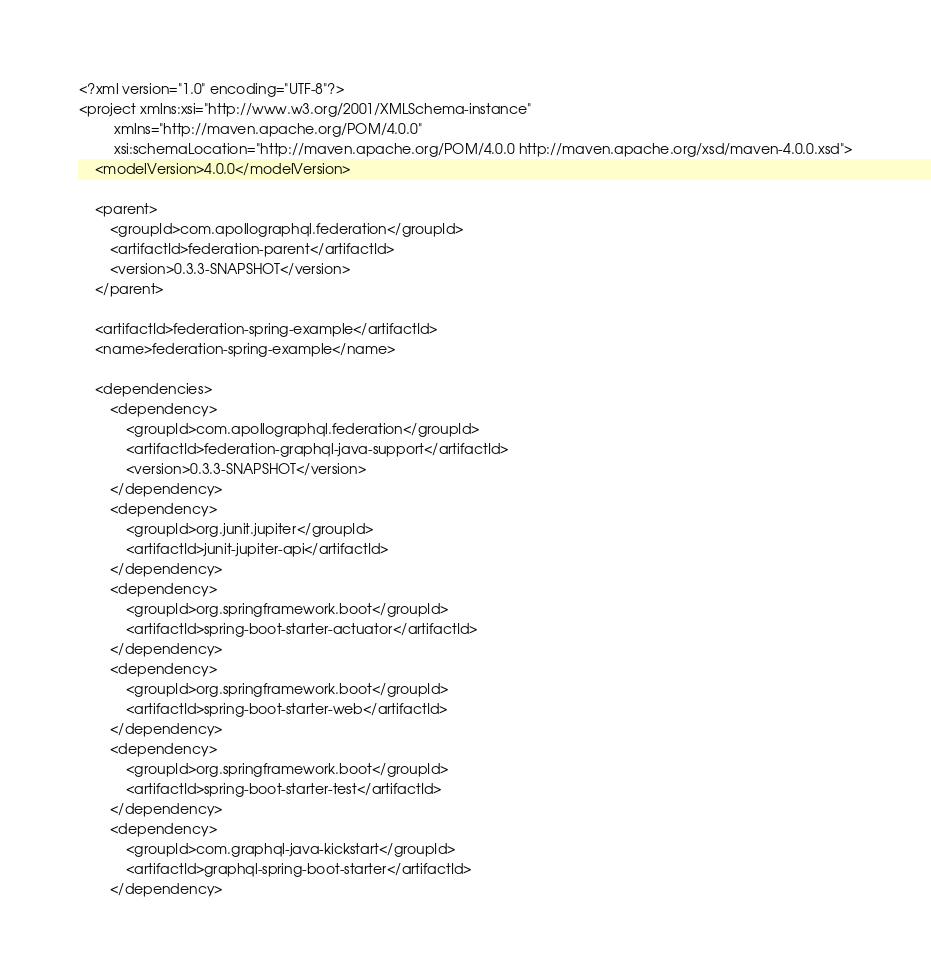Convert code to text. <code><loc_0><loc_0><loc_500><loc_500><_XML_><?xml version="1.0" encoding="UTF-8"?>
<project xmlns:xsi="http://www.w3.org/2001/XMLSchema-instance"
         xmlns="http://maven.apache.org/POM/4.0.0"
         xsi:schemaLocation="http://maven.apache.org/POM/4.0.0 http://maven.apache.org/xsd/maven-4.0.0.xsd">
    <modelVersion>4.0.0</modelVersion>

    <parent>
        <groupId>com.apollographql.federation</groupId>
        <artifactId>federation-parent</artifactId>
        <version>0.3.3-SNAPSHOT</version>
    </parent>

    <artifactId>federation-spring-example</artifactId>
    <name>federation-spring-example</name>

    <dependencies>
        <dependency>
            <groupId>com.apollographql.federation</groupId>
            <artifactId>federation-graphql-java-support</artifactId>
            <version>0.3.3-SNAPSHOT</version>
        </dependency>
        <dependency>
            <groupId>org.junit.jupiter</groupId>
            <artifactId>junit-jupiter-api</artifactId>
        </dependency>
        <dependency>
            <groupId>org.springframework.boot</groupId>
            <artifactId>spring-boot-starter-actuator</artifactId>
        </dependency>
        <dependency>
            <groupId>org.springframework.boot</groupId>
            <artifactId>spring-boot-starter-web</artifactId>
        </dependency>
        <dependency>
            <groupId>org.springframework.boot</groupId>
            <artifactId>spring-boot-starter-test</artifactId>
        </dependency>
        <dependency>
            <groupId>com.graphql-java-kickstart</groupId>
            <artifactId>graphql-spring-boot-starter</artifactId>
        </dependency></code> 